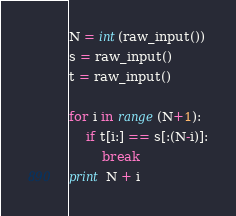<code> <loc_0><loc_0><loc_500><loc_500><_Python_>N = int(raw_input())
s = raw_input()
t = raw_input()

for i in range(N+1):
    if t[i:] == s[:(N-i)]:
        break
print N + i</code> 